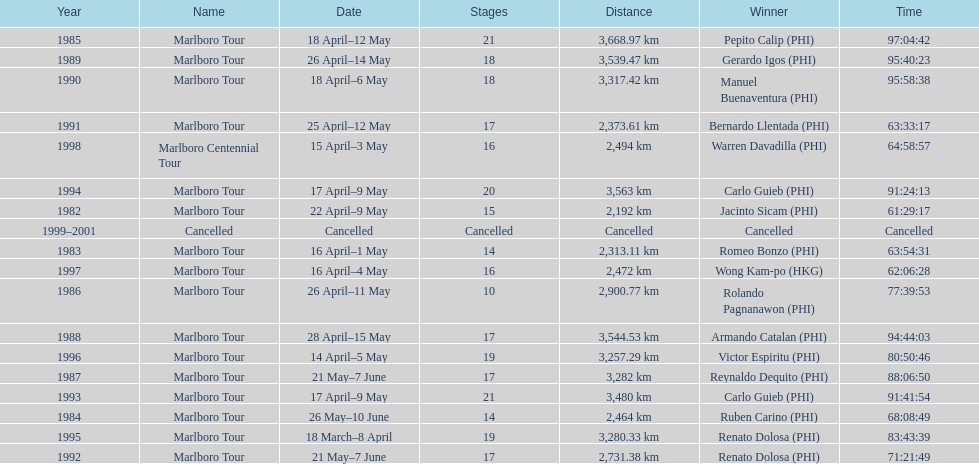Who is listed below romeo bonzo? Ruben Carino (PHI). Write the full table. {'header': ['Year', 'Name', 'Date', 'Stages', 'Distance', 'Winner', 'Time'], 'rows': [['1985', 'Marlboro Tour', '18 April–12 May', '21', '3,668.97\xa0km', 'Pepito Calip\xa0(PHI)', '97:04:42'], ['1989', 'Marlboro Tour', '26 April–14 May', '18', '3,539.47\xa0km', 'Gerardo Igos\xa0(PHI)', '95:40:23'], ['1990', 'Marlboro Tour', '18 April–6 May', '18', '3,317.42\xa0km', 'Manuel Buenaventura\xa0(PHI)', '95:58:38'], ['1991', 'Marlboro Tour', '25 April–12 May', '17', '2,373.61\xa0km', 'Bernardo Llentada\xa0(PHI)', '63:33:17'], ['1998', 'Marlboro Centennial Tour', '15 April–3 May', '16', '2,494\xa0km', 'Warren Davadilla\xa0(PHI)', '64:58:57'], ['1994', 'Marlboro Tour', '17 April–9 May', '20', '3,563\xa0km', 'Carlo Guieb\xa0(PHI)', '91:24:13'], ['1982', 'Marlboro Tour', '22 April–9 May', '15', '2,192\xa0km', 'Jacinto Sicam\xa0(PHI)', '61:29:17'], ['1999–2001', 'Cancelled', 'Cancelled', 'Cancelled', 'Cancelled', 'Cancelled', 'Cancelled'], ['1983', 'Marlboro Tour', '16 April–1 May', '14', '2,313.11\xa0km', 'Romeo Bonzo\xa0(PHI)', '63:54:31'], ['1997', 'Marlboro Tour', '16 April–4 May', '16', '2,472\xa0km', 'Wong Kam-po\xa0(HKG)', '62:06:28'], ['1986', 'Marlboro Tour', '26 April–11 May', '10', '2,900.77\xa0km', 'Rolando Pagnanawon\xa0(PHI)', '77:39:53'], ['1988', 'Marlboro Tour', '28 April–15 May', '17', '3,544.53\xa0km', 'Armando Catalan\xa0(PHI)', '94:44:03'], ['1996', 'Marlboro Tour', '14 April–5 May', '19', '3,257.29\xa0km', 'Victor Espiritu\xa0(PHI)', '80:50:46'], ['1987', 'Marlboro Tour', '21 May–7 June', '17', '3,282\xa0km', 'Reynaldo Dequito\xa0(PHI)', '88:06:50'], ['1993', 'Marlboro Tour', '17 April–9 May', '21', '3,480\xa0km', 'Carlo Guieb\xa0(PHI)', '91:41:54'], ['1984', 'Marlboro Tour', '26 May–10 June', '14', '2,464\xa0km', 'Ruben Carino\xa0(PHI)', '68:08:49'], ['1995', 'Marlboro Tour', '18 March–8 April', '19', '3,280.33\xa0km', 'Renato Dolosa\xa0(PHI)', '83:43:39'], ['1992', 'Marlboro Tour', '21 May–7 June', '17', '2,731.38\xa0km', 'Renato Dolosa\xa0(PHI)', '71:21:49']]} 